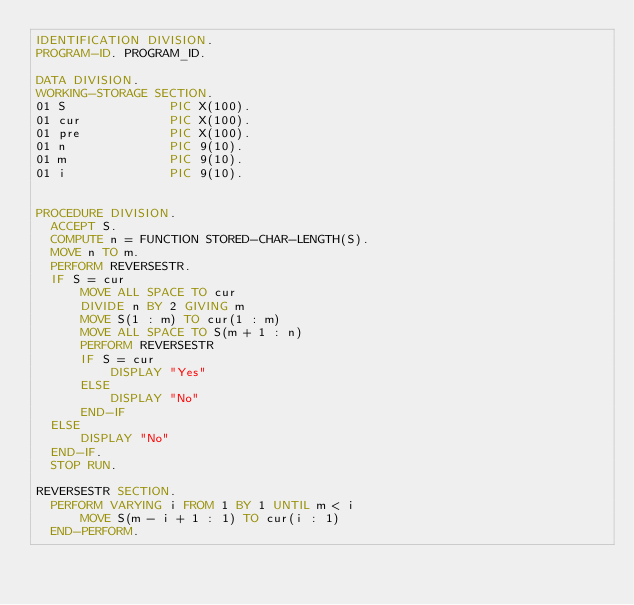<code> <loc_0><loc_0><loc_500><loc_500><_COBOL_>IDENTIFICATION DIVISION.
PROGRAM-ID. PROGRAM_ID.

DATA DIVISION.
WORKING-STORAGE SECTION.
01 S              PIC X(100).
01 cur            PIC X(100).
01 pre            PIC X(100).
01 n              PIC 9(10).
01 m              PIC 9(10).
01 i              PIC 9(10).


PROCEDURE DIVISION.
  ACCEPT S.
  COMPUTE n = FUNCTION STORED-CHAR-LENGTH(S).
  MOVE n TO m.
  PERFORM REVERSESTR.
  IF S = cur
      MOVE ALL SPACE TO cur
      DIVIDE n BY 2 GIVING m
      MOVE S(1 : m) TO cur(1 : m)
      MOVE ALL SPACE TO S(m + 1 : n)
      PERFORM REVERSESTR
      IF S = cur
          DISPLAY "Yes"
      ELSE
          DISPLAY "No"
      END-IF
  ELSE
      DISPLAY "No"
  END-IF.
  STOP RUN.

REVERSESTR SECTION.
  PERFORM VARYING i FROM 1 BY 1 UNTIL m < i
      MOVE S(m - i + 1 : 1) TO cur(i : 1)
  END-PERFORM.
</code> 